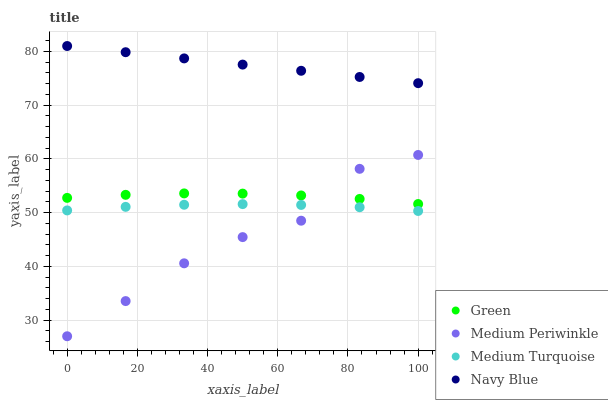Does Medium Periwinkle have the minimum area under the curve?
Answer yes or no. Yes. Does Navy Blue have the maximum area under the curve?
Answer yes or no. Yes. Does Green have the minimum area under the curve?
Answer yes or no. No. Does Green have the maximum area under the curve?
Answer yes or no. No. Is Navy Blue the smoothest?
Answer yes or no. Yes. Is Medium Periwinkle the roughest?
Answer yes or no. Yes. Is Green the smoothest?
Answer yes or no. No. Is Green the roughest?
Answer yes or no. No. Does Medium Periwinkle have the lowest value?
Answer yes or no. Yes. Does Green have the lowest value?
Answer yes or no. No. Does Navy Blue have the highest value?
Answer yes or no. Yes. Does Green have the highest value?
Answer yes or no. No. Is Medium Turquoise less than Navy Blue?
Answer yes or no. Yes. Is Navy Blue greater than Medium Periwinkle?
Answer yes or no. Yes. Does Medium Periwinkle intersect Green?
Answer yes or no. Yes. Is Medium Periwinkle less than Green?
Answer yes or no. No. Is Medium Periwinkle greater than Green?
Answer yes or no. No. Does Medium Turquoise intersect Navy Blue?
Answer yes or no. No. 